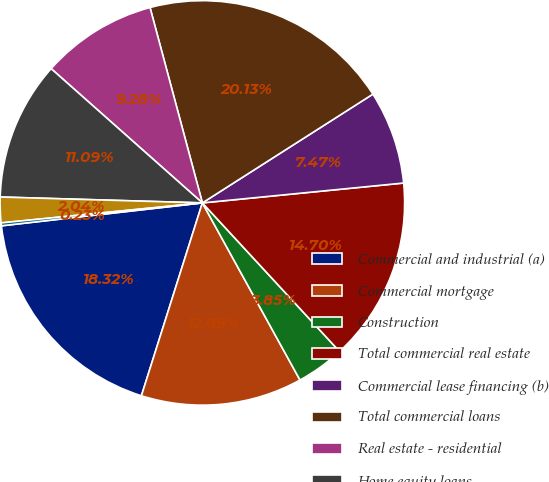<chart> <loc_0><loc_0><loc_500><loc_500><pie_chart><fcel>Commercial and industrial (a)<fcel>Commercial mortgage<fcel>Construction<fcel>Total commercial real estate<fcel>Commercial lease financing (b)<fcel>Total commercial loans<fcel>Real estate - residential<fcel>Home equity loans<fcel>Consumer direct loans<fcel>Credit cards<nl><fcel>18.32%<fcel>12.89%<fcel>3.85%<fcel>14.7%<fcel>7.47%<fcel>20.13%<fcel>9.28%<fcel>11.09%<fcel>2.04%<fcel>0.23%<nl></chart> 